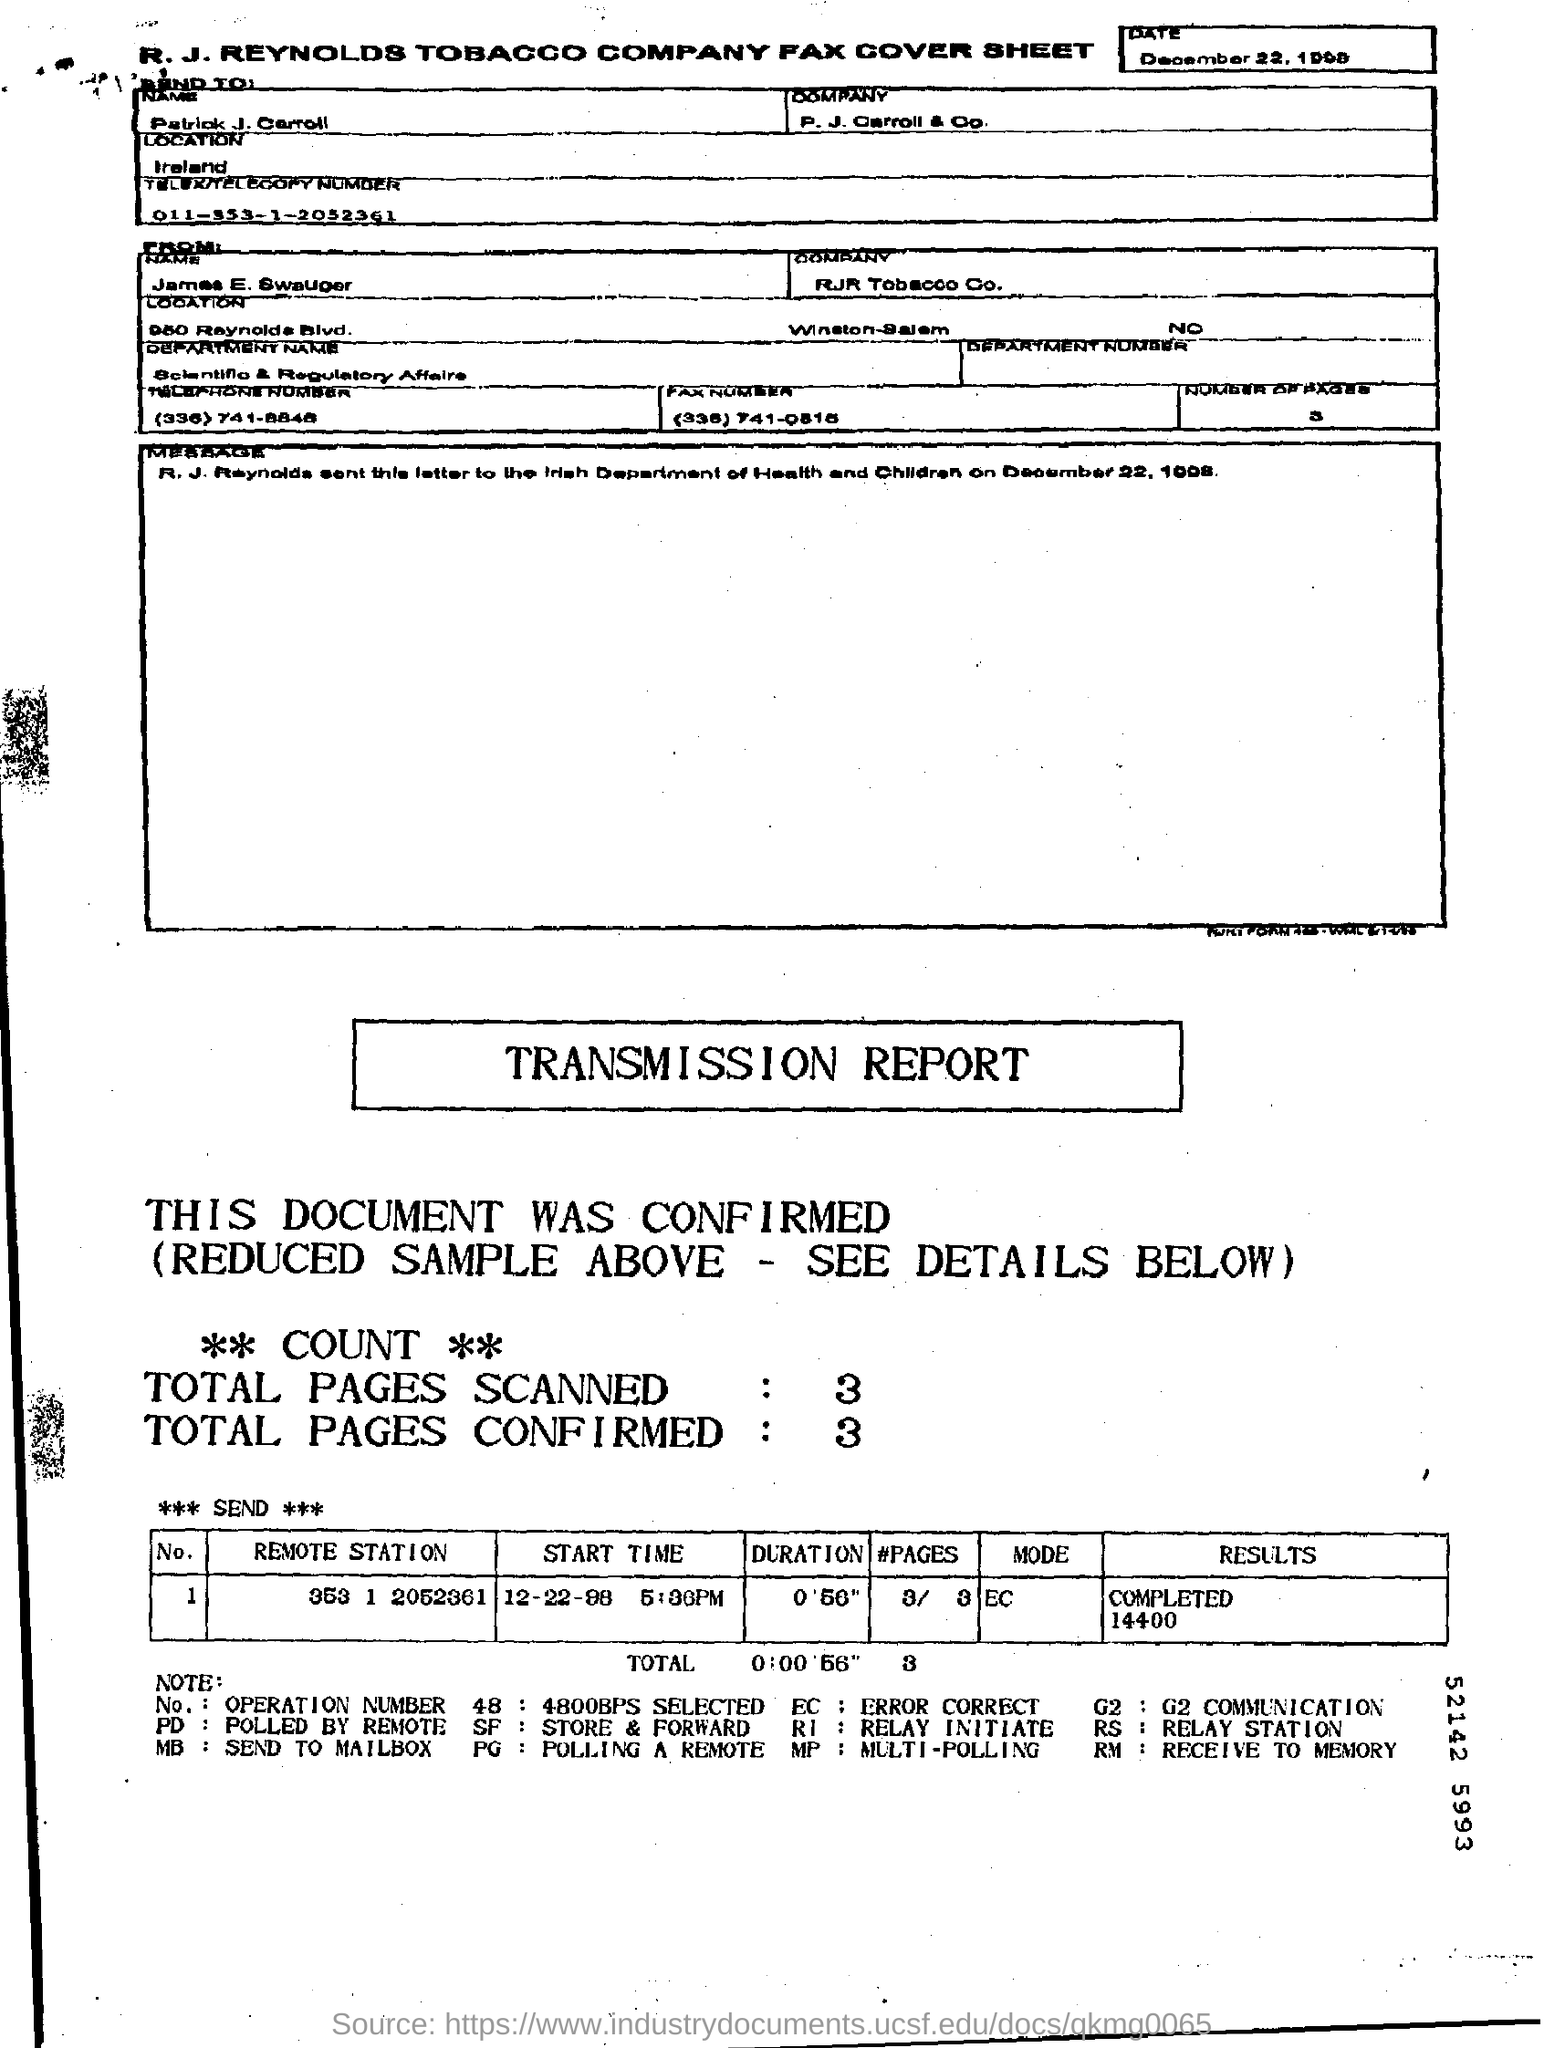Draw attention to some important aspects in this diagram. The fax is sent to Patrick J. Carroll. James is from the Scientific & Regulatory Affairs department. Patrick J. Carroll is employed by P. J. Carroll & Co. 